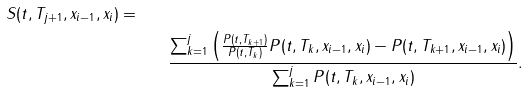Convert formula to latex. <formula><loc_0><loc_0><loc_500><loc_500>{ S ( t , T _ { j + 1 } , x _ { i - 1 } , x _ { i } ) = } \quad \\ & \frac { \sum _ { k = 1 } ^ { j } \left ( \frac { P ( t , T _ { k + 1 } ) } { P ( t , T _ { k } ) } P ( t , T _ { k } , x _ { i - 1 } , x _ { i } ) - P ( t , T _ { k + 1 } , x _ { i - 1 } , x _ { i } ) \right ) } { \sum _ { k = 1 } ^ { j } P ( t , T _ { k } , x _ { i - 1 } , x _ { i } ) } .</formula> 